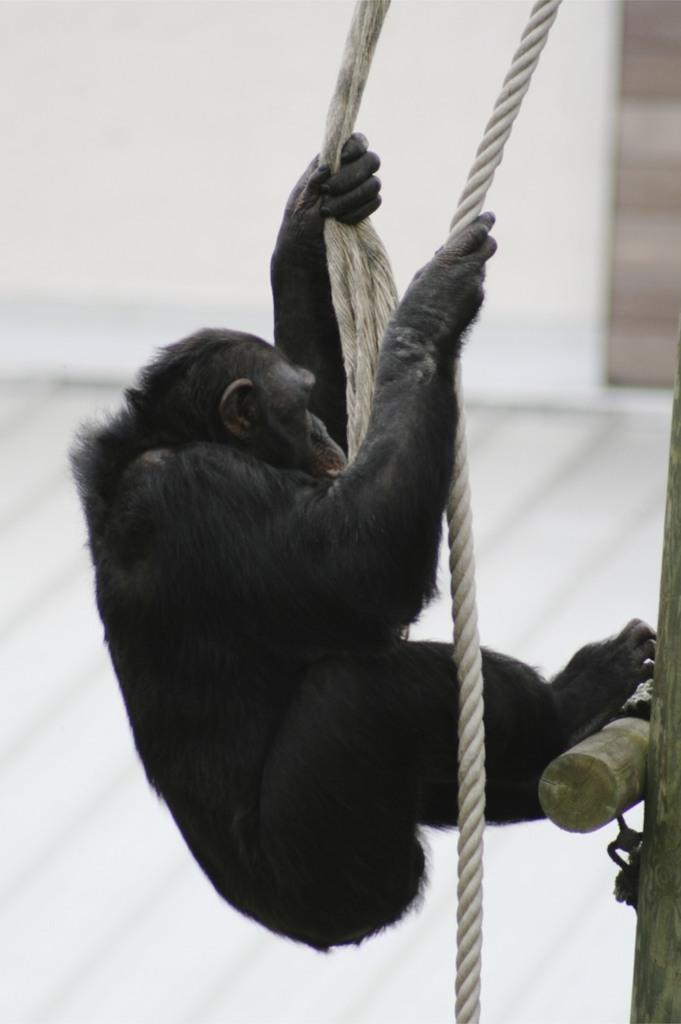What type of animal can be seen in the image? There is an animal in the image, but its specific type is not mentioned in the facts. What is the animal doing in the image? The animal is holding a rope in the image. What other objects are present in the image? There are wooden sticks in the image. What can be seen in the background of the image? There appears to be a wall in the background of the image. What type of pest is bothering the animal's brother in the image? There is no mention of a pest or the animal's brother in the image, so this question cannot be answered definitively. 